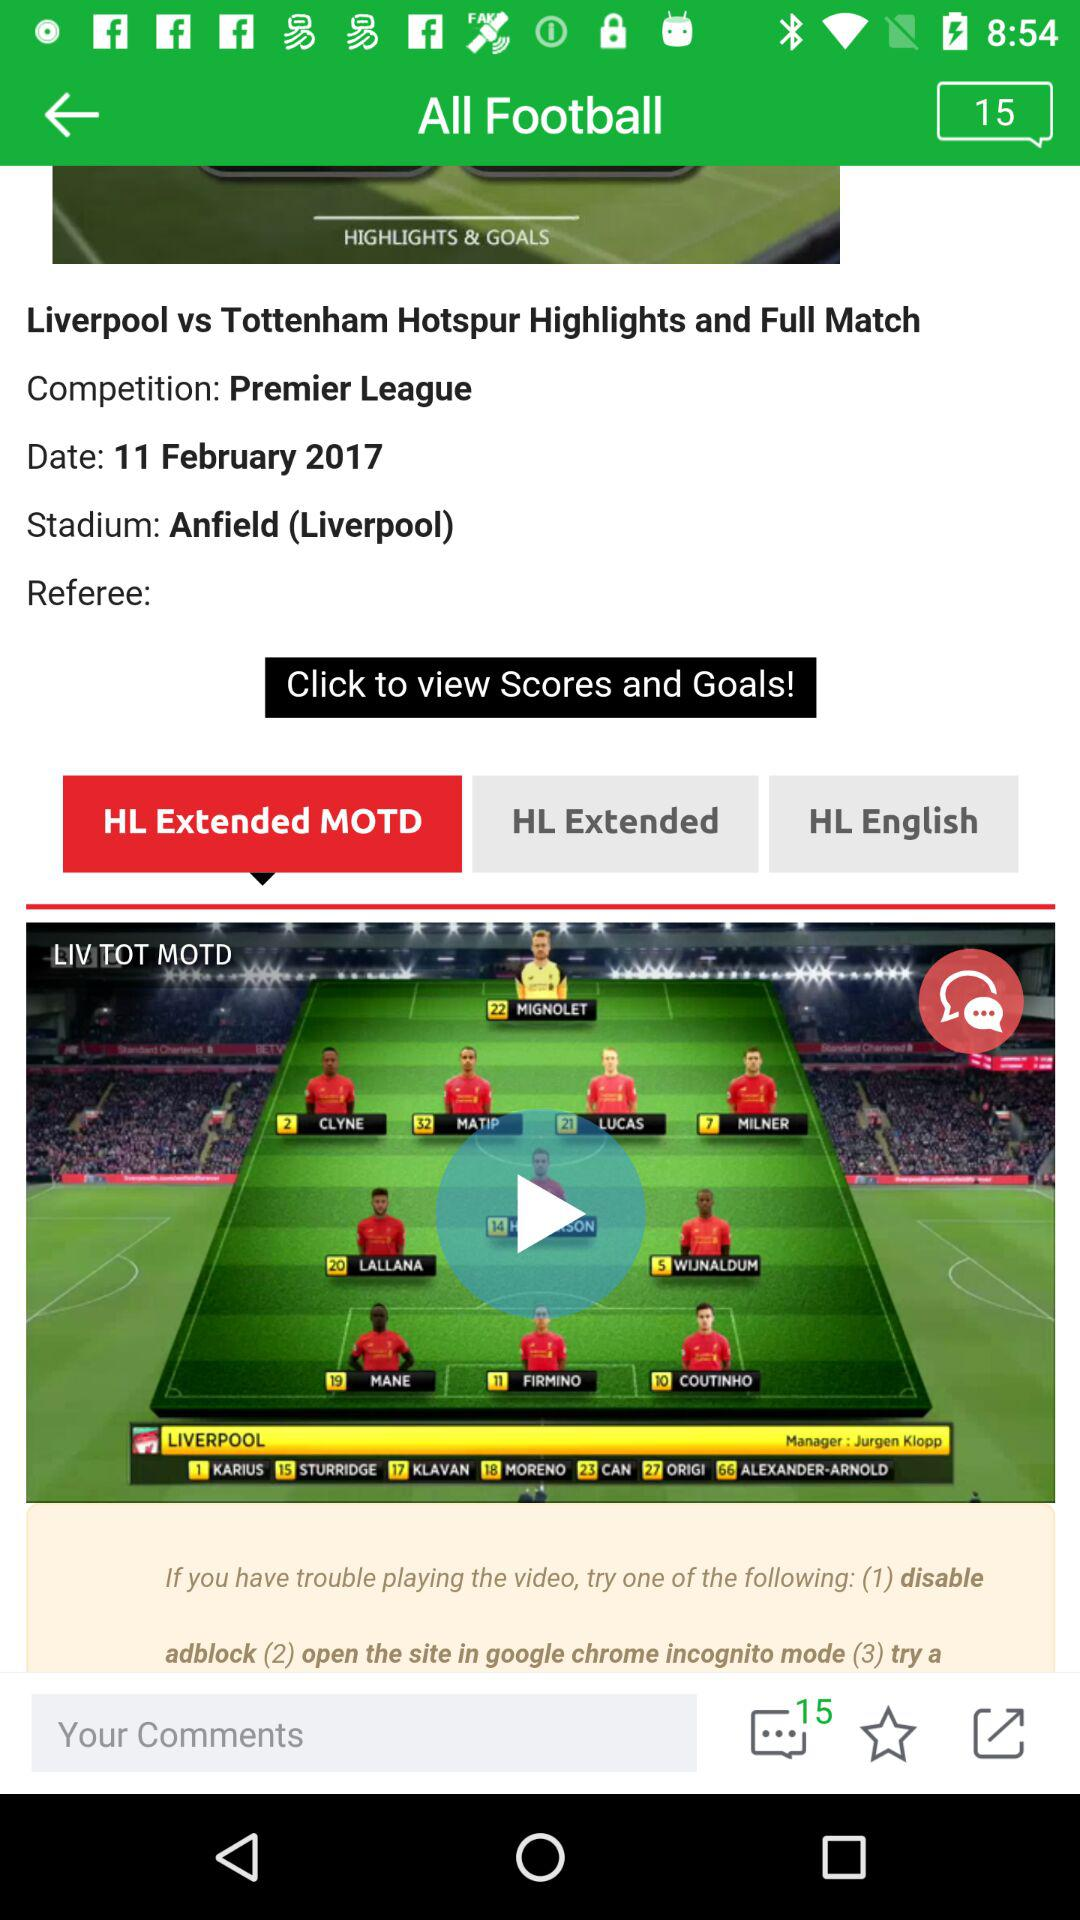What is the name of the competition? The name of the competition is "Premier League". 